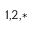<formula> <loc_0><loc_0><loc_500><loc_500>^ { 1 , 2 , * }</formula> 